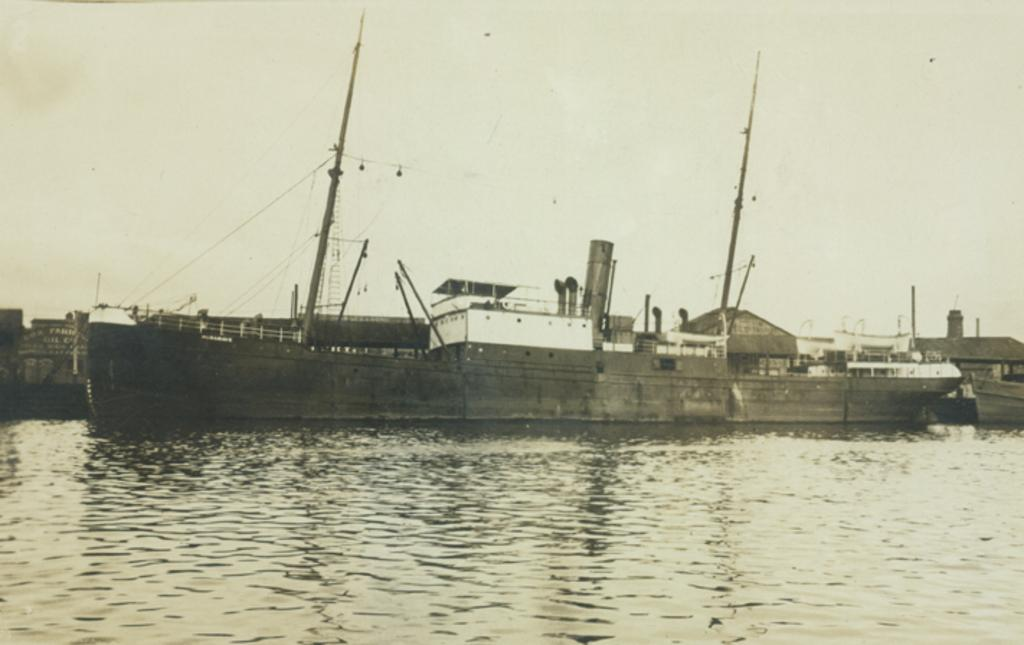What type of boat is in the image? There is a Clyde steamer in the image. Where is the steamer located in the image? The steamer is in the water. What else can be seen in the image besides the steamer? The sky is visible in the image. What type of channel can be seen in the image? There is no channel present in the image; it features a Clyde steamer in the water. Is the thing in the image made of metal or wood? The provided facts do not specify the material of the Clyde steamer, so it cannot be determined from the image. 